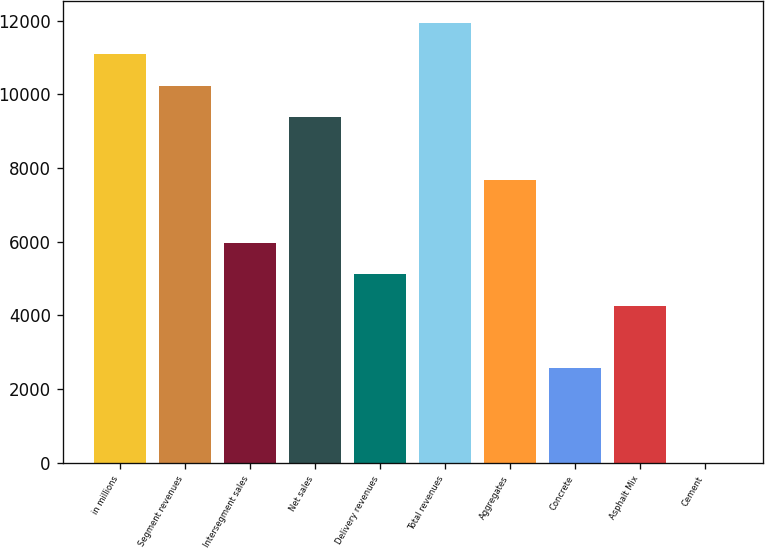<chart> <loc_0><loc_0><loc_500><loc_500><bar_chart><fcel>in millions<fcel>Segment revenues<fcel>Intersegment sales<fcel>Net sales<fcel>Delivery revenues<fcel>Total revenues<fcel>Aggregates<fcel>Concrete<fcel>Asphalt Mix<fcel>Cement<nl><fcel>11083.9<fcel>10231.4<fcel>5969.09<fcel>9378.97<fcel>5116.62<fcel>11936.4<fcel>7674.03<fcel>2559.21<fcel>4264.15<fcel>1.8<nl></chart> 